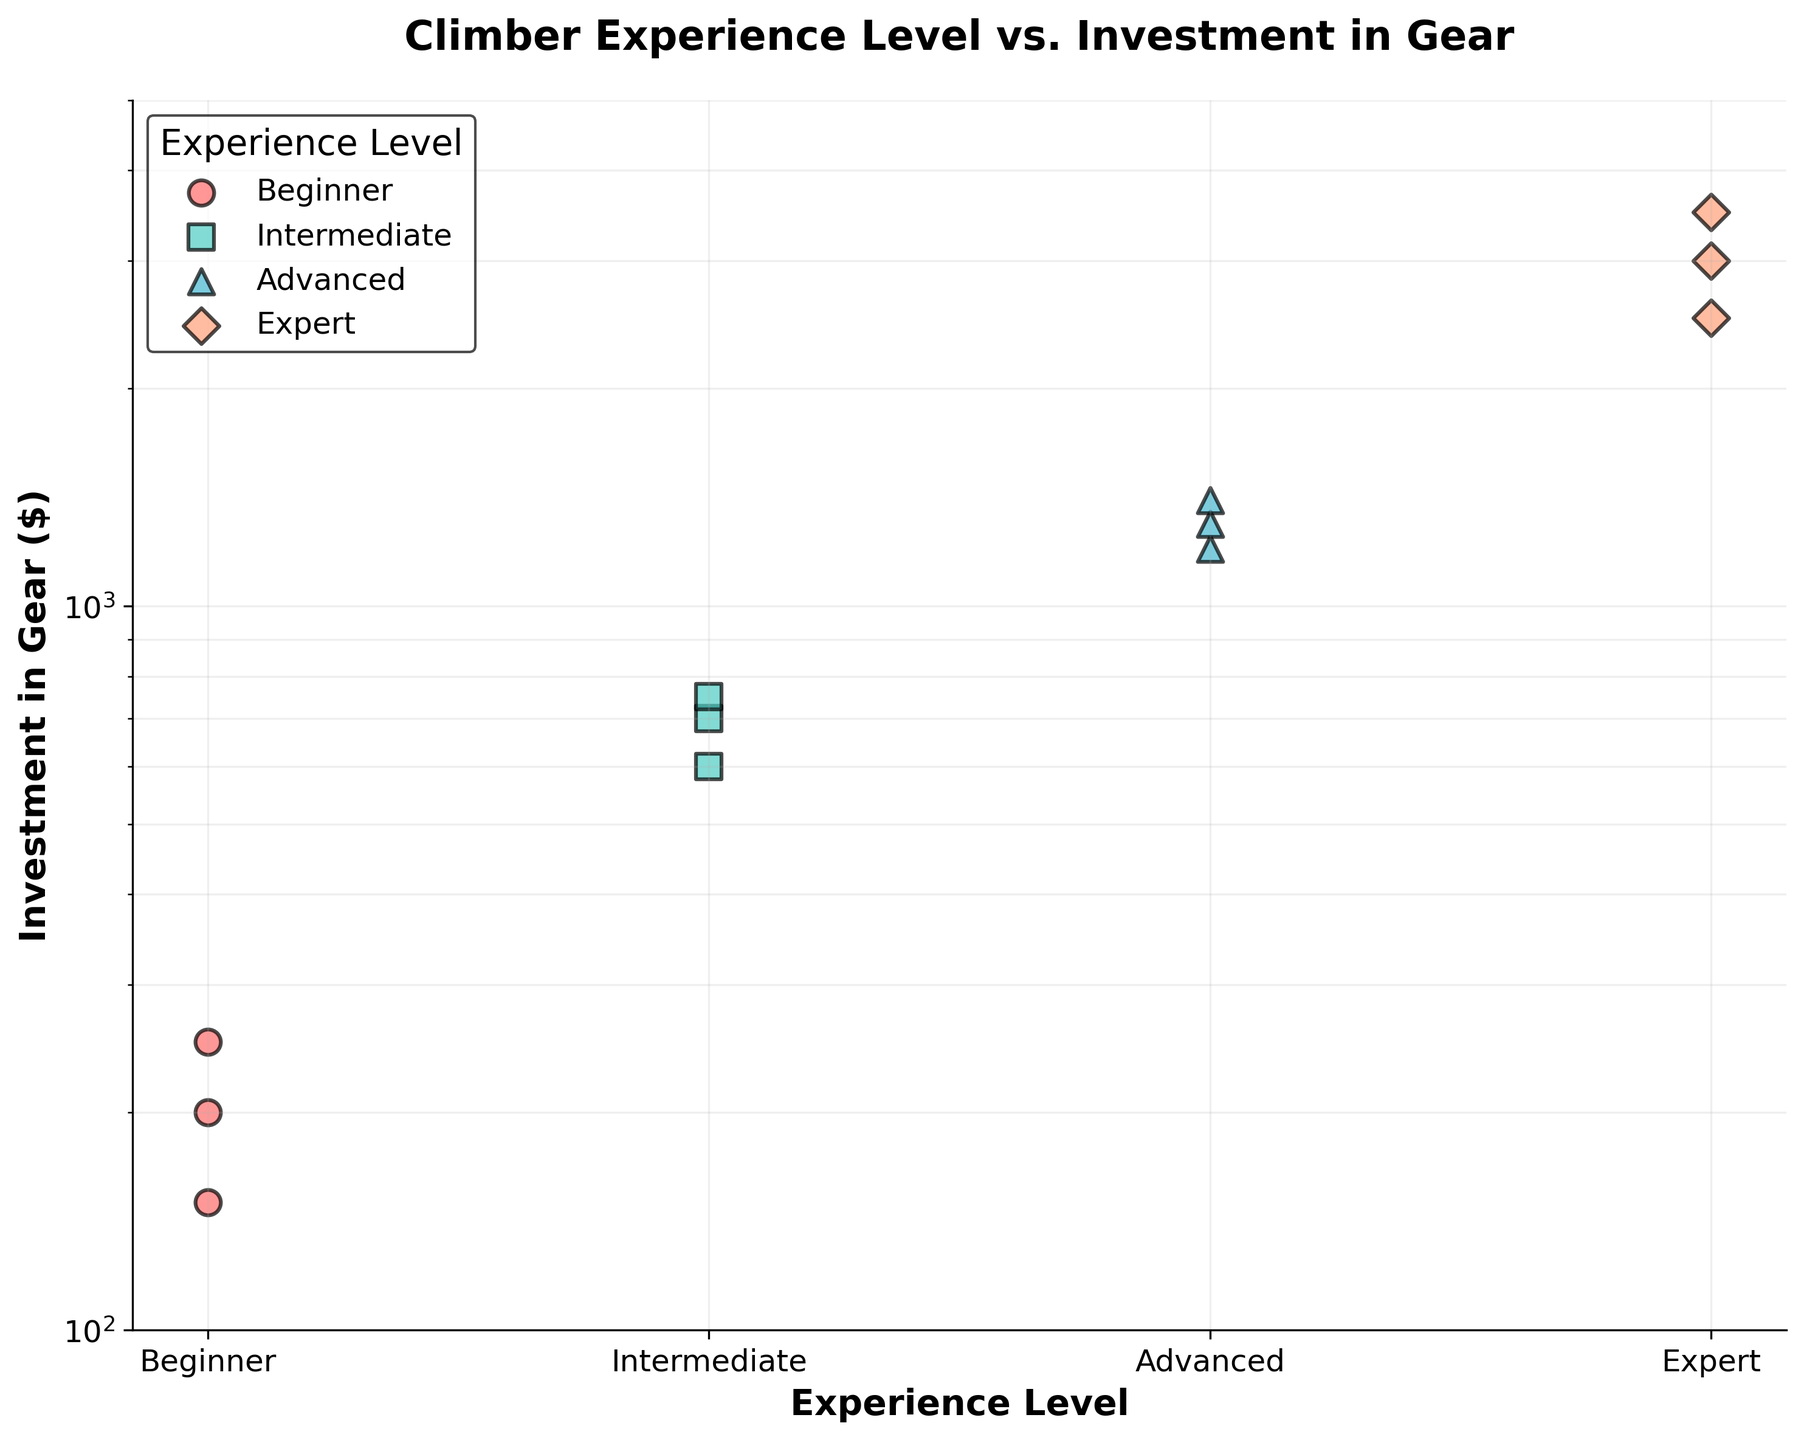What is the title of the figure? The title of the figure can be found at the top center. It is written in bold text for easy identification.
Answer: Climber Experience Level vs. Investment in Gear How many experience levels are there in the data set? Count the unique labels on the x-axis. Each label represents a different experience level.
Answer: 4 What is the range of dollars invested in gear for Intermediate climbers? Identify the lowest and highest points for the Intermediate level on the y-axis.
Answer: 600 - 750 Which experience level has the highest investment in climbing gear? Look for the group with data points placed highest on the y-axis.
Answer: Expert How does the median investment for Advanced climbers compare to that for Intermediate climbers? Find the middle value of the data points for both groups. Compare these two values. For Advanced: 1200, 1300, 1400 (Median: 1300). For Intermediate: 600, 700, 750 (Median: 700).
Answer: Advanced climbers have a higher median investment than Intermediate climbers What do the colors and markers represent in the scatter plot? These elements distinguish the data points for each experience level. Each color and marker combination represents a different experience level.
Answer: Different experience levels Which group shows the widest range in investment amounts? Identify the group with the largest difference between the highest and lowest data points. Intermediate: 150, Expert: 1000, Beginner: 100, Advanced: 200
Answer: Expert Among the Expert climbers, what is the highest investment in gear? Look for the highest data point among the Expert climbers on the y-axis.
Answer: 3500 dollars Comparing the median investments of Beginner and Expert climbers, how much higher is the Expert median? Calculate the median for both groups: Beginner (150, 200, 250, Median: 200); Expert (2500, 3000, 3500, Median: 3000). Then subtract the Beginner median from the Expert median. 3000 - 200 = 2800.
Answer: 2800 dollars 